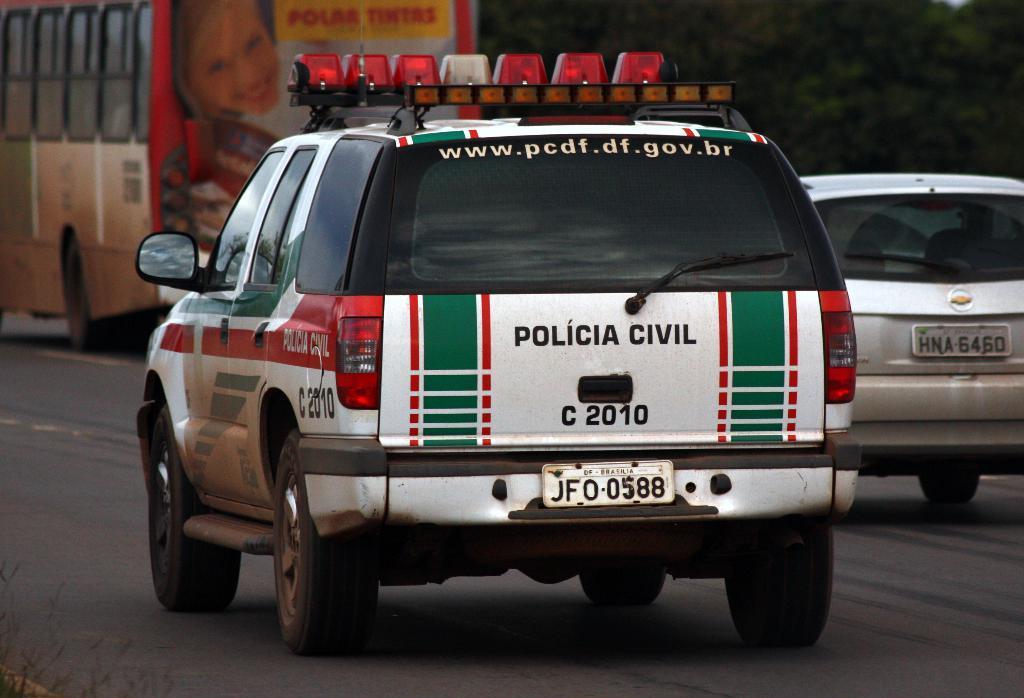Please provide a concise description of this image. In this image, there are vehicles on the road. In the background, I can see the trees. 